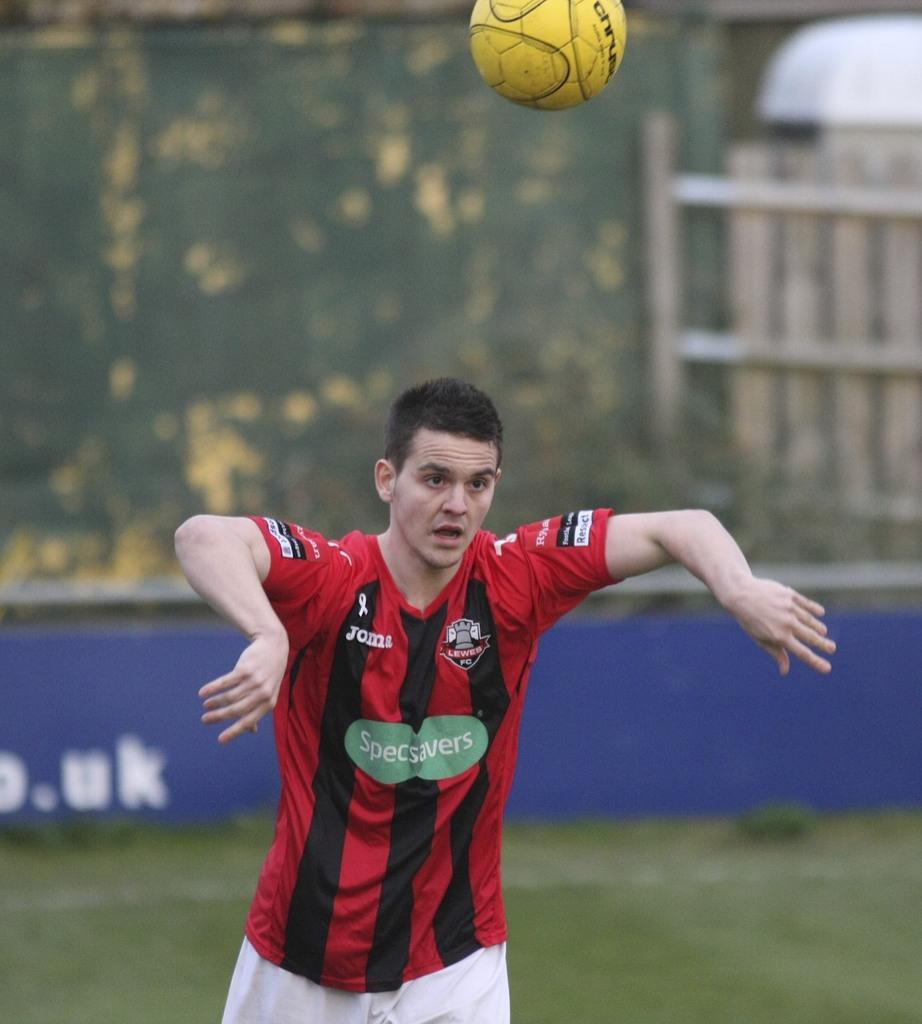<image>
Provide a brief description of the given image. a soccer player in a red and black stripped jersey with the logo specsavers on the front 